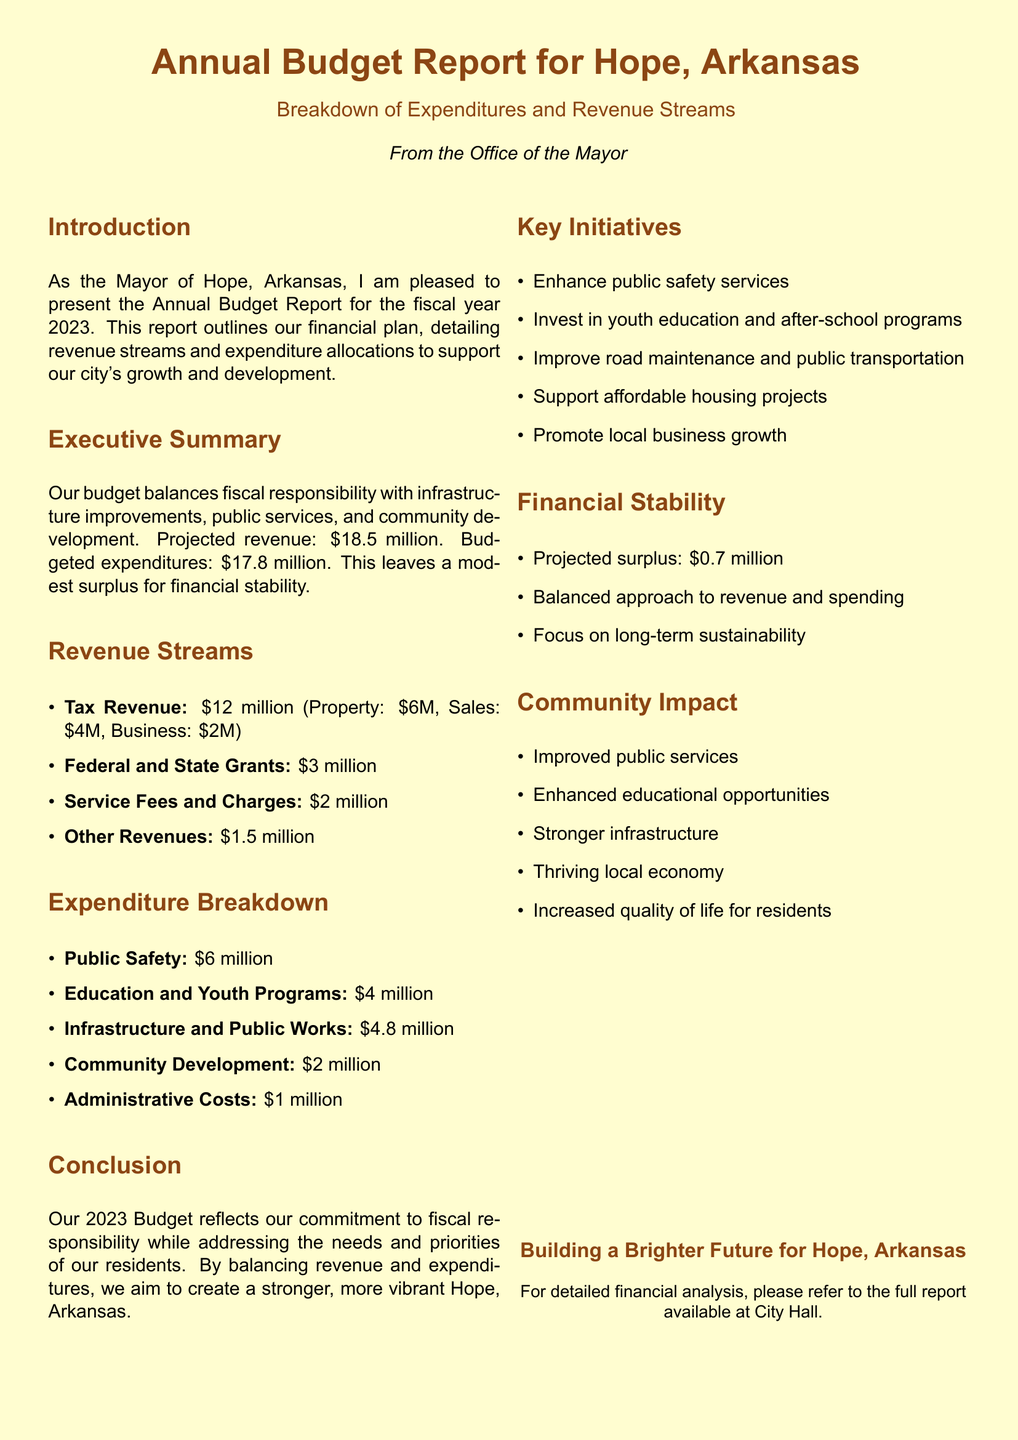what is the projected revenue for 2023? The projected revenue is detailed in the Executive Summary section of the report.
Answer: $18.5 million how much is allocated to public safety? The expenditure allocation for public safety is listed in the Expenditure Breakdown section.
Answer: $6 million what is the total amount for federal and state grants? The total for federal and state grants is mentioned in the Revenue Streams section.
Answer: $3 million how much is the budgeted expenditure? The budgeted expenditure is stated in the Executive Summary.
Answer: $17.8 million what is the projected surplus amount? The projected surplus is provided in the Financial Stability section of the report.
Answer: $0.7 million how much is dedicated to education and youth programs? The allocation for education and youth programs is specified in the Expenditure Breakdown section.
Answer: $4 million what are the key initiatives listed in the report? Key initiatives are outlined in their own section, detailing the focus areas of the budget.
Answer: Enhance public safety services, Invest in youth education and after-school programs, Improve road maintenance and public transportation, Support affordable housing projects, Promote local business growth what percentage of the total revenue comes from tax revenue? The tax revenue figure is provided in the Revenue Streams section, and percentage can be derived based on the total revenue.
Answer: 64.86% what is the amount allocated for community development? The amount for community development can be found in the Expenditure Breakdown section.
Answer: $2 million 